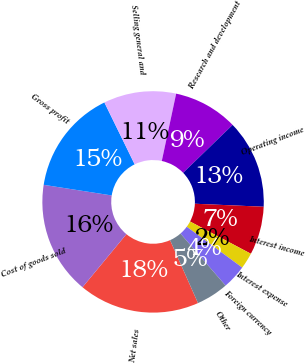Convert chart. <chart><loc_0><loc_0><loc_500><loc_500><pie_chart><fcel>Net sales<fcel>Cost of goods sold<fcel>Gross profit<fcel>Selling general and<fcel>Research and development<fcel>Operating income<fcel>Interest income<fcel>Interest expense<fcel>Foreign currency<fcel>Other<nl><fcel>17.65%<fcel>16.47%<fcel>15.29%<fcel>10.59%<fcel>9.41%<fcel>12.94%<fcel>7.06%<fcel>2.35%<fcel>3.53%<fcel>4.71%<nl></chart> 